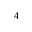Convert formula to latex. <formula><loc_0><loc_0><loc_500><loc_500>_ { 4 }</formula> 